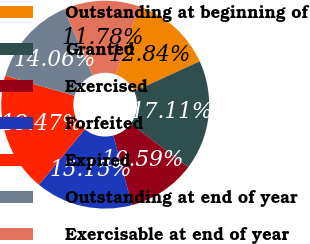Convert chart. <chart><loc_0><loc_0><loc_500><loc_500><pie_chart><fcel>Outstanding at beginning of<fcel>Granted<fcel>Exercised<fcel>Forfeited<fcel>Expired<fcel>Outstanding at end of year<fcel>Exercisable at end of year<nl><fcel>12.84%<fcel>17.11%<fcel>10.59%<fcel>15.15%<fcel>18.47%<fcel>14.06%<fcel>11.78%<nl></chart> 